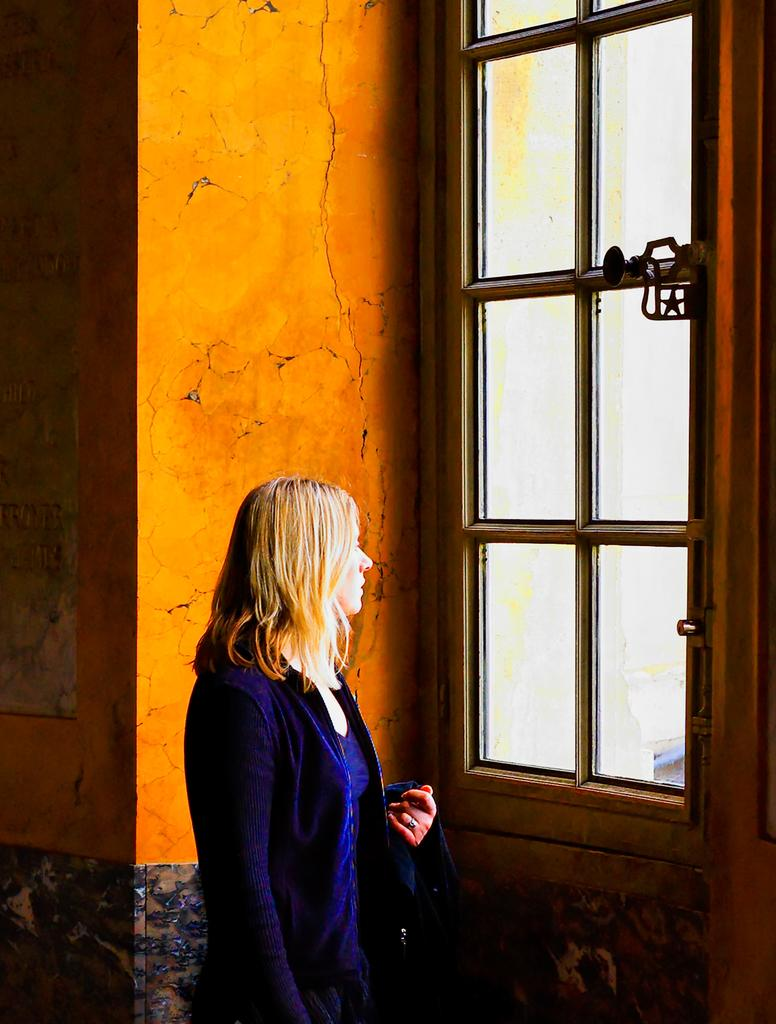Who is the main subject in the image? There is a lady standing in the center of the image. What can be seen in the background of the image? There is a wall and a window in the background of the image. What is the purpose of the handle associated with the window? The handle is used to open or close the window. What material is used for the window? There is glass visible in the window. What type of police response can be seen in the image? There is no police response present in the image. What answer is the lady providing in the image? The image does not show the lady providing any answer, as it is a still image. 